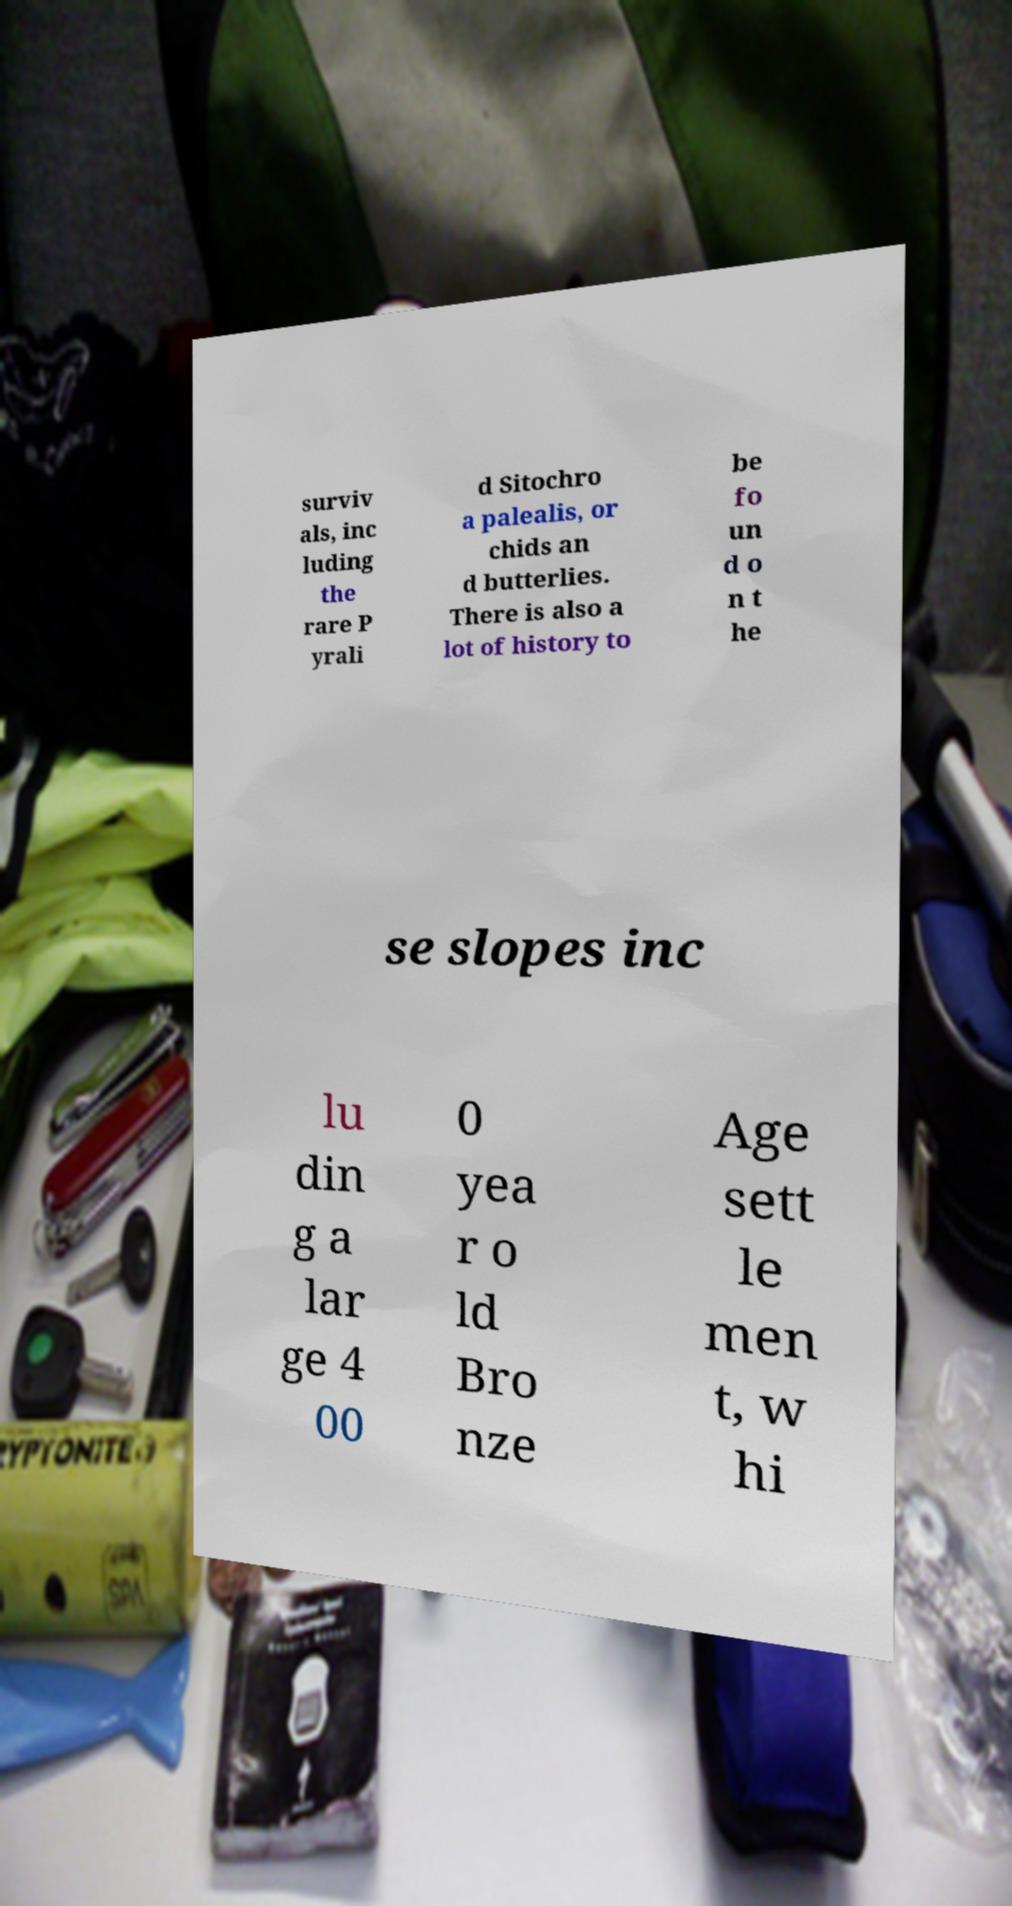I need the written content from this picture converted into text. Can you do that? surviv als, inc luding the rare P yrali d Sitochro a palealis, or chids an d butterlies. There is also a lot of history to be fo un d o n t he se slopes inc lu din g a lar ge 4 00 0 yea r o ld Bro nze Age sett le men t, w hi 